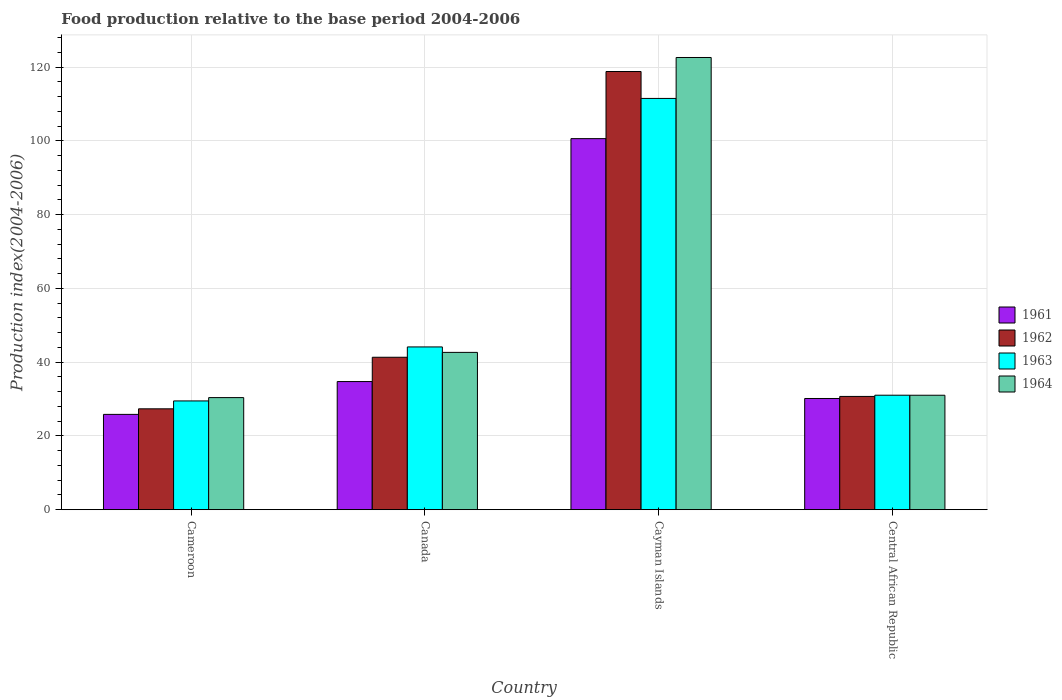How many groups of bars are there?
Make the answer very short. 4. Are the number of bars per tick equal to the number of legend labels?
Give a very brief answer. Yes. How many bars are there on the 1st tick from the left?
Ensure brevity in your answer.  4. How many bars are there on the 2nd tick from the right?
Offer a terse response. 4. What is the label of the 3rd group of bars from the left?
Offer a very short reply. Cayman Islands. What is the food production index in 1961 in Central African Republic?
Your answer should be very brief. 30.15. Across all countries, what is the maximum food production index in 1962?
Your answer should be compact. 118.8. Across all countries, what is the minimum food production index in 1963?
Ensure brevity in your answer.  29.49. In which country was the food production index in 1964 maximum?
Keep it short and to the point. Cayman Islands. In which country was the food production index in 1964 minimum?
Ensure brevity in your answer.  Cameroon. What is the total food production index in 1964 in the graph?
Your response must be concise. 226.67. What is the difference between the food production index in 1963 in Cameroon and that in Canada?
Ensure brevity in your answer.  -14.64. What is the difference between the food production index in 1962 in Canada and the food production index in 1961 in Cameroon?
Keep it short and to the point. 15.49. What is the average food production index in 1962 per country?
Provide a succinct answer. 54.55. What is the difference between the food production index of/in 1964 and food production index of/in 1963 in Cameroon?
Ensure brevity in your answer.  0.9. In how many countries, is the food production index in 1962 greater than 24?
Offer a very short reply. 4. What is the ratio of the food production index in 1963 in Cameroon to that in Central African Republic?
Offer a terse response. 0.95. What is the difference between the highest and the second highest food production index in 1962?
Offer a terse response. -77.47. What is the difference between the highest and the lowest food production index in 1961?
Provide a short and direct response. 74.76. In how many countries, is the food production index in 1962 greater than the average food production index in 1962 taken over all countries?
Your response must be concise. 1. Is the sum of the food production index in 1964 in Canada and Central African Republic greater than the maximum food production index in 1961 across all countries?
Your answer should be very brief. No. Is it the case that in every country, the sum of the food production index in 1964 and food production index in 1961 is greater than the sum of food production index in 1963 and food production index in 1962?
Your response must be concise. No. Is it the case that in every country, the sum of the food production index in 1963 and food production index in 1961 is greater than the food production index in 1962?
Make the answer very short. Yes. How many bars are there?
Your answer should be compact. 16. Are all the bars in the graph horizontal?
Provide a short and direct response. No. What is the difference between two consecutive major ticks on the Y-axis?
Your response must be concise. 20. Are the values on the major ticks of Y-axis written in scientific E-notation?
Make the answer very short. No. Does the graph contain grids?
Your answer should be compact. Yes. Where does the legend appear in the graph?
Keep it short and to the point. Center right. What is the title of the graph?
Your answer should be compact. Food production relative to the base period 2004-2006. Does "1974" appear as one of the legend labels in the graph?
Provide a succinct answer. No. What is the label or title of the X-axis?
Provide a short and direct response. Country. What is the label or title of the Y-axis?
Your answer should be very brief. Production index(2004-2006). What is the Production index(2004-2006) in 1961 in Cameroon?
Keep it short and to the point. 25.84. What is the Production index(2004-2006) in 1962 in Cameroon?
Your answer should be compact. 27.35. What is the Production index(2004-2006) in 1963 in Cameroon?
Give a very brief answer. 29.49. What is the Production index(2004-2006) in 1964 in Cameroon?
Provide a short and direct response. 30.39. What is the Production index(2004-2006) in 1961 in Canada?
Provide a succinct answer. 34.74. What is the Production index(2004-2006) in 1962 in Canada?
Ensure brevity in your answer.  41.33. What is the Production index(2004-2006) in 1963 in Canada?
Keep it short and to the point. 44.13. What is the Production index(2004-2006) of 1964 in Canada?
Your response must be concise. 42.65. What is the Production index(2004-2006) of 1961 in Cayman Islands?
Offer a very short reply. 100.6. What is the Production index(2004-2006) of 1962 in Cayman Islands?
Offer a very short reply. 118.8. What is the Production index(2004-2006) of 1963 in Cayman Islands?
Ensure brevity in your answer.  111.5. What is the Production index(2004-2006) in 1964 in Cayman Islands?
Offer a terse response. 122.6. What is the Production index(2004-2006) in 1961 in Central African Republic?
Give a very brief answer. 30.15. What is the Production index(2004-2006) of 1962 in Central African Republic?
Ensure brevity in your answer.  30.71. What is the Production index(2004-2006) of 1963 in Central African Republic?
Ensure brevity in your answer.  31.04. What is the Production index(2004-2006) of 1964 in Central African Republic?
Your response must be concise. 31.03. Across all countries, what is the maximum Production index(2004-2006) of 1961?
Give a very brief answer. 100.6. Across all countries, what is the maximum Production index(2004-2006) in 1962?
Your answer should be compact. 118.8. Across all countries, what is the maximum Production index(2004-2006) of 1963?
Offer a very short reply. 111.5. Across all countries, what is the maximum Production index(2004-2006) of 1964?
Keep it short and to the point. 122.6. Across all countries, what is the minimum Production index(2004-2006) in 1961?
Keep it short and to the point. 25.84. Across all countries, what is the minimum Production index(2004-2006) of 1962?
Provide a succinct answer. 27.35. Across all countries, what is the minimum Production index(2004-2006) of 1963?
Offer a very short reply. 29.49. Across all countries, what is the minimum Production index(2004-2006) of 1964?
Offer a terse response. 30.39. What is the total Production index(2004-2006) of 1961 in the graph?
Provide a succinct answer. 191.33. What is the total Production index(2004-2006) in 1962 in the graph?
Offer a very short reply. 218.19. What is the total Production index(2004-2006) of 1963 in the graph?
Your answer should be very brief. 216.16. What is the total Production index(2004-2006) of 1964 in the graph?
Keep it short and to the point. 226.67. What is the difference between the Production index(2004-2006) of 1961 in Cameroon and that in Canada?
Provide a short and direct response. -8.9. What is the difference between the Production index(2004-2006) in 1962 in Cameroon and that in Canada?
Offer a terse response. -13.98. What is the difference between the Production index(2004-2006) of 1963 in Cameroon and that in Canada?
Your answer should be compact. -14.64. What is the difference between the Production index(2004-2006) of 1964 in Cameroon and that in Canada?
Give a very brief answer. -12.26. What is the difference between the Production index(2004-2006) of 1961 in Cameroon and that in Cayman Islands?
Make the answer very short. -74.76. What is the difference between the Production index(2004-2006) in 1962 in Cameroon and that in Cayman Islands?
Make the answer very short. -91.45. What is the difference between the Production index(2004-2006) in 1963 in Cameroon and that in Cayman Islands?
Offer a very short reply. -82.01. What is the difference between the Production index(2004-2006) in 1964 in Cameroon and that in Cayman Islands?
Your answer should be very brief. -92.21. What is the difference between the Production index(2004-2006) of 1961 in Cameroon and that in Central African Republic?
Keep it short and to the point. -4.31. What is the difference between the Production index(2004-2006) in 1962 in Cameroon and that in Central African Republic?
Provide a short and direct response. -3.36. What is the difference between the Production index(2004-2006) of 1963 in Cameroon and that in Central African Republic?
Offer a terse response. -1.55. What is the difference between the Production index(2004-2006) in 1964 in Cameroon and that in Central African Republic?
Your answer should be very brief. -0.64. What is the difference between the Production index(2004-2006) of 1961 in Canada and that in Cayman Islands?
Your response must be concise. -65.86. What is the difference between the Production index(2004-2006) of 1962 in Canada and that in Cayman Islands?
Provide a short and direct response. -77.47. What is the difference between the Production index(2004-2006) in 1963 in Canada and that in Cayman Islands?
Keep it short and to the point. -67.37. What is the difference between the Production index(2004-2006) in 1964 in Canada and that in Cayman Islands?
Ensure brevity in your answer.  -79.95. What is the difference between the Production index(2004-2006) of 1961 in Canada and that in Central African Republic?
Provide a succinct answer. 4.59. What is the difference between the Production index(2004-2006) in 1962 in Canada and that in Central African Republic?
Give a very brief answer. 10.62. What is the difference between the Production index(2004-2006) in 1963 in Canada and that in Central African Republic?
Ensure brevity in your answer.  13.09. What is the difference between the Production index(2004-2006) of 1964 in Canada and that in Central African Republic?
Your answer should be compact. 11.62. What is the difference between the Production index(2004-2006) in 1961 in Cayman Islands and that in Central African Republic?
Your answer should be very brief. 70.45. What is the difference between the Production index(2004-2006) in 1962 in Cayman Islands and that in Central African Republic?
Offer a very short reply. 88.09. What is the difference between the Production index(2004-2006) of 1963 in Cayman Islands and that in Central African Republic?
Ensure brevity in your answer.  80.46. What is the difference between the Production index(2004-2006) of 1964 in Cayman Islands and that in Central African Republic?
Provide a succinct answer. 91.57. What is the difference between the Production index(2004-2006) of 1961 in Cameroon and the Production index(2004-2006) of 1962 in Canada?
Offer a terse response. -15.49. What is the difference between the Production index(2004-2006) of 1961 in Cameroon and the Production index(2004-2006) of 1963 in Canada?
Your answer should be very brief. -18.29. What is the difference between the Production index(2004-2006) of 1961 in Cameroon and the Production index(2004-2006) of 1964 in Canada?
Provide a short and direct response. -16.81. What is the difference between the Production index(2004-2006) of 1962 in Cameroon and the Production index(2004-2006) of 1963 in Canada?
Make the answer very short. -16.78. What is the difference between the Production index(2004-2006) of 1962 in Cameroon and the Production index(2004-2006) of 1964 in Canada?
Your answer should be very brief. -15.3. What is the difference between the Production index(2004-2006) of 1963 in Cameroon and the Production index(2004-2006) of 1964 in Canada?
Keep it short and to the point. -13.16. What is the difference between the Production index(2004-2006) of 1961 in Cameroon and the Production index(2004-2006) of 1962 in Cayman Islands?
Offer a terse response. -92.96. What is the difference between the Production index(2004-2006) in 1961 in Cameroon and the Production index(2004-2006) in 1963 in Cayman Islands?
Provide a succinct answer. -85.66. What is the difference between the Production index(2004-2006) of 1961 in Cameroon and the Production index(2004-2006) of 1964 in Cayman Islands?
Your response must be concise. -96.76. What is the difference between the Production index(2004-2006) of 1962 in Cameroon and the Production index(2004-2006) of 1963 in Cayman Islands?
Ensure brevity in your answer.  -84.15. What is the difference between the Production index(2004-2006) of 1962 in Cameroon and the Production index(2004-2006) of 1964 in Cayman Islands?
Offer a terse response. -95.25. What is the difference between the Production index(2004-2006) in 1963 in Cameroon and the Production index(2004-2006) in 1964 in Cayman Islands?
Provide a succinct answer. -93.11. What is the difference between the Production index(2004-2006) in 1961 in Cameroon and the Production index(2004-2006) in 1962 in Central African Republic?
Offer a very short reply. -4.87. What is the difference between the Production index(2004-2006) in 1961 in Cameroon and the Production index(2004-2006) in 1964 in Central African Republic?
Give a very brief answer. -5.19. What is the difference between the Production index(2004-2006) of 1962 in Cameroon and the Production index(2004-2006) of 1963 in Central African Republic?
Your answer should be compact. -3.69. What is the difference between the Production index(2004-2006) of 1962 in Cameroon and the Production index(2004-2006) of 1964 in Central African Republic?
Ensure brevity in your answer.  -3.68. What is the difference between the Production index(2004-2006) of 1963 in Cameroon and the Production index(2004-2006) of 1964 in Central African Republic?
Offer a terse response. -1.54. What is the difference between the Production index(2004-2006) of 1961 in Canada and the Production index(2004-2006) of 1962 in Cayman Islands?
Provide a short and direct response. -84.06. What is the difference between the Production index(2004-2006) in 1961 in Canada and the Production index(2004-2006) in 1963 in Cayman Islands?
Offer a very short reply. -76.76. What is the difference between the Production index(2004-2006) in 1961 in Canada and the Production index(2004-2006) in 1964 in Cayman Islands?
Give a very brief answer. -87.86. What is the difference between the Production index(2004-2006) in 1962 in Canada and the Production index(2004-2006) in 1963 in Cayman Islands?
Offer a very short reply. -70.17. What is the difference between the Production index(2004-2006) in 1962 in Canada and the Production index(2004-2006) in 1964 in Cayman Islands?
Your answer should be compact. -81.27. What is the difference between the Production index(2004-2006) of 1963 in Canada and the Production index(2004-2006) of 1964 in Cayman Islands?
Provide a succinct answer. -78.47. What is the difference between the Production index(2004-2006) of 1961 in Canada and the Production index(2004-2006) of 1962 in Central African Republic?
Give a very brief answer. 4.03. What is the difference between the Production index(2004-2006) in 1961 in Canada and the Production index(2004-2006) in 1963 in Central African Republic?
Give a very brief answer. 3.7. What is the difference between the Production index(2004-2006) of 1961 in Canada and the Production index(2004-2006) of 1964 in Central African Republic?
Offer a very short reply. 3.71. What is the difference between the Production index(2004-2006) of 1962 in Canada and the Production index(2004-2006) of 1963 in Central African Republic?
Provide a short and direct response. 10.29. What is the difference between the Production index(2004-2006) in 1962 in Canada and the Production index(2004-2006) in 1964 in Central African Republic?
Your answer should be very brief. 10.3. What is the difference between the Production index(2004-2006) of 1963 in Canada and the Production index(2004-2006) of 1964 in Central African Republic?
Offer a very short reply. 13.1. What is the difference between the Production index(2004-2006) in 1961 in Cayman Islands and the Production index(2004-2006) in 1962 in Central African Republic?
Your answer should be very brief. 69.89. What is the difference between the Production index(2004-2006) in 1961 in Cayman Islands and the Production index(2004-2006) in 1963 in Central African Republic?
Your answer should be compact. 69.56. What is the difference between the Production index(2004-2006) in 1961 in Cayman Islands and the Production index(2004-2006) in 1964 in Central African Republic?
Provide a short and direct response. 69.57. What is the difference between the Production index(2004-2006) of 1962 in Cayman Islands and the Production index(2004-2006) of 1963 in Central African Republic?
Offer a very short reply. 87.76. What is the difference between the Production index(2004-2006) of 1962 in Cayman Islands and the Production index(2004-2006) of 1964 in Central African Republic?
Provide a short and direct response. 87.77. What is the difference between the Production index(2004-2006) in 1963 in Cayman Islands and the Production index(2004-2006) in 1964 in Central African Republic?
Make the answer very short. 80.47. What is the average Production index(2004-2006) in 1961 per country?
Give a very brief answer. 47.83. What is the average Production index(2004-2006) in 1962 per country?
Give a very brief answer. 54.55. What is the average Production index(2004-2006) of 1963 per country?
Provide a short and direct response. 54.04. What is the average Production index(2004-2006) of 1964 per country?
Keep it short and to the point. 56.67. What is the difference between the Production index(2004-2006) of 1961 and Production index(2004-2006) of 1962 in Cameroon?
Provide a succinct answer. -1.51. What is the difference between the Production index(2004-2006) of 1961 and Production index(2004-2006) of 1963 in Cameroon?
Ensure brevity in your answer.  -3.65. What is the difference between the Production index(2004-2006) of 1961 and Production index(2004-2006) of 1964 in Cameroon?
Give a very brief answer. -4.55. What is the difference between the Production index(2004-2006) in 1962 and Production index(2004-2006) in 1963 in Cameroon?
Ensure brevity in your answer.  -2.14. What is the difference between the Production index(2004-2006) of 1962 and Production index(2004-2006) of 1964 in Cameroon?
Provide a succinct answer. -3.04. What is the difference between the Production index(2004-2006) of 1961 and Production index(2004-2006) of 1962 in Canada?
Provide a short and direct response. -6.59. What is the difference between the Production index(2004-2006) of 1961 and Production index(2004-2006) of 1963 in Canada?
Your answer should be very brief. -9.39. What is the difference between the Production index(2004-2006) in 1961 and Production index(2004-2006) in 1964 in Canada?
Offer a very short reply. -7.91. What is the difference between the Production index(2004-2006) in 1962 and Production index(2004-2006) in 1963 in Canada?
Keep it short and to the point. -2.8. What is the difference between the Production index(2004-2006) in 1962 and Production index(2004-2006) in 1964 in Canada?
Your response must be concise. -1.32. What is the difference between the Production index(2004-2006) in 1963 and Production index(2004-2006) in 1964 in Canada?
Provide a succinct answer. 1.48. What is the difference between the Production index(2004-2006) in 1961 and Production index(2004-2006) in 1962 in Cayman Islands?
Give a very brief answer. -18.2. What is the difference between the Production index(2004-2006) in 1961 and Production index(2004-2006) in 1964 in Cayman Islands?
Your answer should be very brief. -22. What is the difference between the Production index(2004-2006) in 1962 and Production index(2004-2006) in 1964 in Cayman Islands?
Give a very brief answer. -3.8. What is the difference between the Production index(2004-2006) in 1963 and Production index(2004-2006) in 1964 in Cayman Islands?
Provide a succinct answer. -11.1. What is the difference between the Production index(2004-2006) in 1961 and Production index(2004-2006) in 1962 in Central African Republic?
Provide a short and direct response. -0.56. What is the difference between the Production index(2004-2006) of 1961 and Production index(2004-2006) of 1963 in Central African Republic?
Your response must be concise. -0.89. What is the difference between the Production index(2004-2006) in 1961 and Production index(2004-2006) in 1964 in Central African Republic?
Make the answer very short. -0.88. What is the difference between the Production index(2004-2006) in 1962 and Production index(2004-2006) in 1963 in Central African Republic?
Keep it short and to the point. -0.33. What is the difference between the Production index(2004-2006) in 1962 and Production index(2004-2006) in 1964 in Central African Republic?
Offer a very short reply. -0.32. What is the difference between the Production index(2004-2006) of 1963 and Production index(2004-2006) of 1964 in Central African Republic?
Your answer should be very brief. 0.01. What is the ratio of the Production index(2004-2006) in 1961 in Cameroon to that in Canada?
Keep it short and to the point. 0.74. What is the ratio of the Production index(2004-2006) of 1962 in Cameroon to that in Canada?
Provide a succinct answer. 0.66. What is the ratio of the Production index(2004-2006) in 1963 in Cameroon to that in Canada?
Make the answer very short. 0.67. What is the ratio of the Production index(2004-2006) in 1964 in Cameroon to that in Canada?
Provide a succinct answer. 0.71. What is the ratio of the Production index(2004-2006) in 1961 in Cameroon to that in Cayman Islands?
Give a very brief answer. 0.26. What is the ratio of the Production index(2004-2006) of 1962 in Cameroon to that in Cayman Islands?
Your answer should be very brief. 0.23. What is the ratio of the Production index(2004-2006) of 1963 in Cameroon to that in Cayman Islands?
Keep it short and to the point. 0.26. What is the ratio of the Production index(2004-2006) in 1964 in Cameroon to that in Cayman Islands?
Your response must be concise. 0.25. What is the ratio of the Production index(2004-2006) in 1961 in Cameroon to that in Central African Republic?
Make the answer very short. 0.86. What is the ratio of the Production index(2004-2006) in 1962 in Cameroon to that in Central African Republic?
Offer a terse response. 0.89. What is the ratio of the Production index(2004-2006) in 1963 in Cameroon to that in Central African Republic?
Your response must be concise. 0.95. What is the ratio of the Production index(2004-2006) in 1964 in Cameroon to that in Central African Republic?
Offer a very short reply. 0.98. What is the ratio of the Production index(2004-2006) of 1961 in Canada to that in Cayman Islands?
Offer a very short reply. 0.35. What is the ratio of the Production index(2004-2006) of 1962 in Canada to that in Cayman Islands?
Offer a terse response. 0.35. What is the ratio of the Production index(2004-2006) in 1963 in Canada to that in Cayman Islands?
Make the answer very short. 0.4. What is the ratio of the Production index(2004-2006) of 1964 in Canada to that in Cayman Islands?
Ensure brevity in your answer.  0.35. What is the ratio of the Production index(2004-2006) of 1961 in Canada to that in Central African Republic?
Keep it short and to the point. 1.15. What is the ratio of the Production index(2004-2006) of 1962 in Canada to that in Central African Republic?
Your answer should be compact. 1.35. What is the ratio of the Production index(2004-2006) of 1963 in Canada to that in Central African Republic?
Offer a terse response. 1.42. What is the ratio of the Production index(2004-2006) of 1964 in Canada to that in Central African Republic?
Keep it short and to the point. 1.37. What is the ratio of the Production index(2004-2006) of 1961 in Cayman Islands to that in Central African Republic?
Provide a short and direct response. 3.34. What is the ratio of the Production index(2004-2006) of 1962 in Cayman Islands to that in Central African Republic?
Keep it short and to the point. 3.87. What is the ratio of the Production index(2004-2006) in 1963 in Cayman Islands to that in Central African Republic?
Provide a short and direct response. 3.59. What is the ratio of the Production index(2004-2006) of 1964 in Cayman Islands to that in Central African Republic?
Give a very brief answer. 3.95. What is the difference between the highest and the second highest Production index(2004-2006) in 1961?
Offer a terse response. 65.86. What is the difference between the highest and the second highest Production index(2004-2006) of 1962?
Provide a short and direct response. 77.47. What is the difference between the highest and the second highest Production index(2004-2006) of 1963?
Offer a very short reply. 67.37. What is the difference between the highest and the second highest Production index(2004-2006) in 1964?
Provide a short and direct response. 79.95. What is the difference between the highest and the lowest Production index(2004-2006) of 1961?
Ensure brevity in your answer.  74.76. What is the difference between the highest and the lowest Production index(2004-2006) of 1962?
Provide a short and direct response. 91.45. What is the difference between the highest and the lowest Production index(2004-2006) of 1963?
Ensure brevity in your answer.  82.01. What is the difference between the highest and the lowest Production index(2004-2006) of 1964?
Provide a short and direct response. 92.21. 